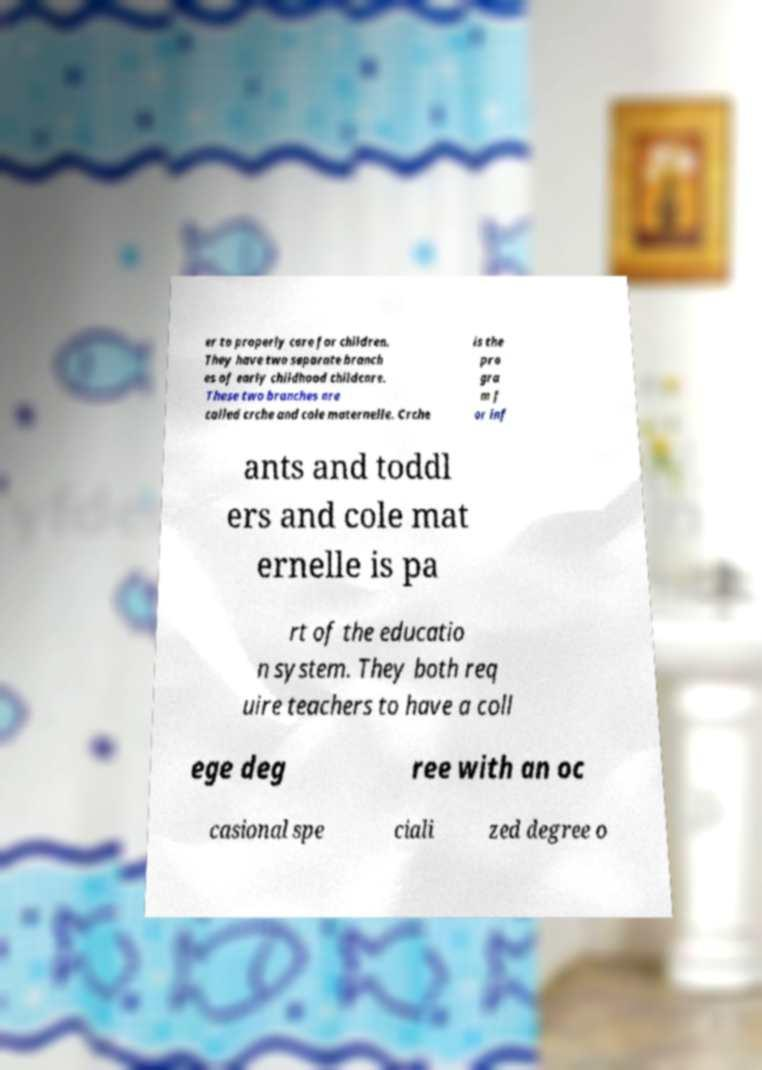There's text embedded in this image that I need extracted. Can you transcribe it verbatim? er to properly care for children. They have two separate branch es of early childhood childcare. These two branches are called crche and cole maternelle. Crche is the pro gra m f or inf ants and toddl ers and cole mat ernelle is pa rt of the educatio n system. They both req uire teachers to have a coll ege deg ree with an oc casional spe ciali zed degree o 